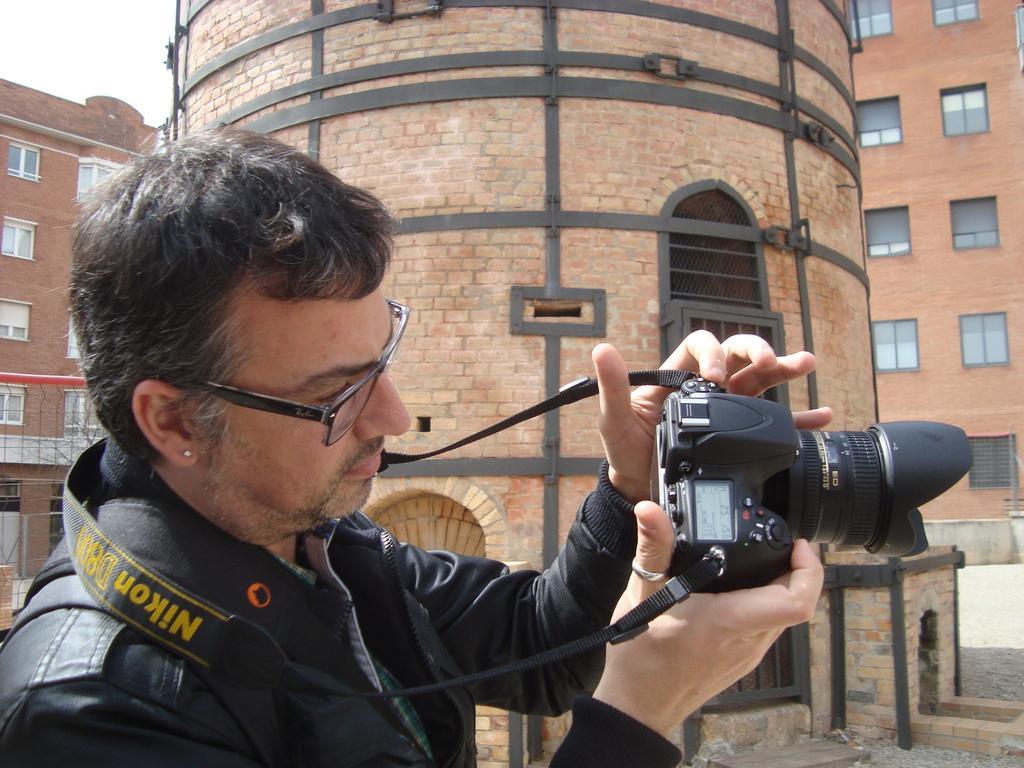Please provide a concise description of this image. In this image there is man wearing a spects and black jacket and he was holding a camera. In the background there is a building with bricks and too many windows. 